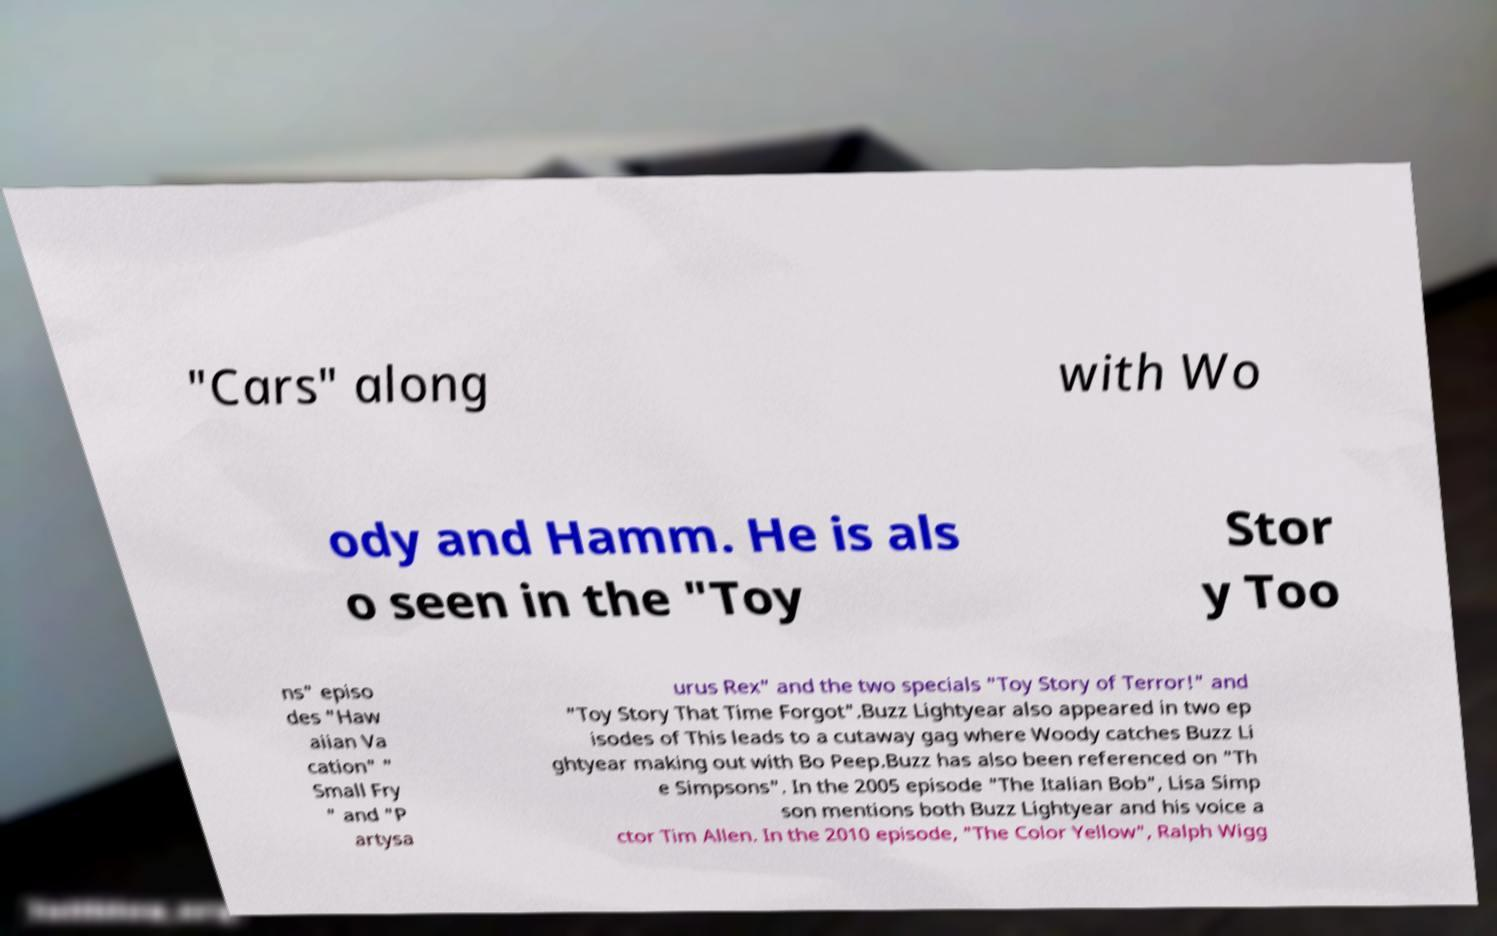There's text embedded in this image that I need extracted. Can you transcribe it verbatim? "Cars" along with Wo ody and Hamm. He is als o seen in the "Toy Stor y Too ns" episo des "Haw aiian Va cation" " Small Fry " and "P artysa urus Rex" and the two specials "Toy Story of Terror!" and "Toy Story That Time Forgot".Buzz Lightyear also appeared in two ep isodes of This leads to a cutaway gag where Woody catches Buzz Li ghtyear making out with Bo Peep.Buzz has also been referenced on "Th e Simpsons". In the 2005 episode "The Italian Bob", Lisa Simp son mentions both Buzz Lightyear and his voice a ctor Tim Allen. In the 2010 episode, "The Color Yellow", Ralph Wigg 